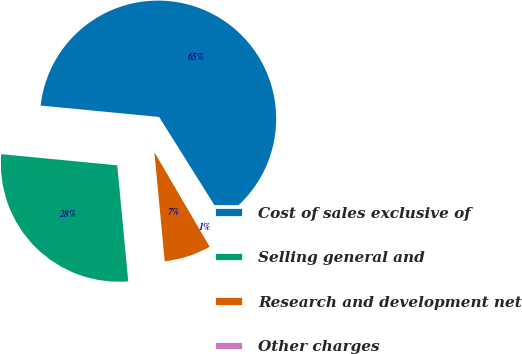Convert chart to OTSL. <chart><loc_0><loc_0><loc_500><loc_500><pie_chart><fcel>Cost of sales exclusive of<fcel>Selling general and<fcel>Research and development net<fcel>Other charges<nl><fcel>64.55%<fcel>28.03%<fcel>6.91%<fcel>0.5%<nl></chart> 